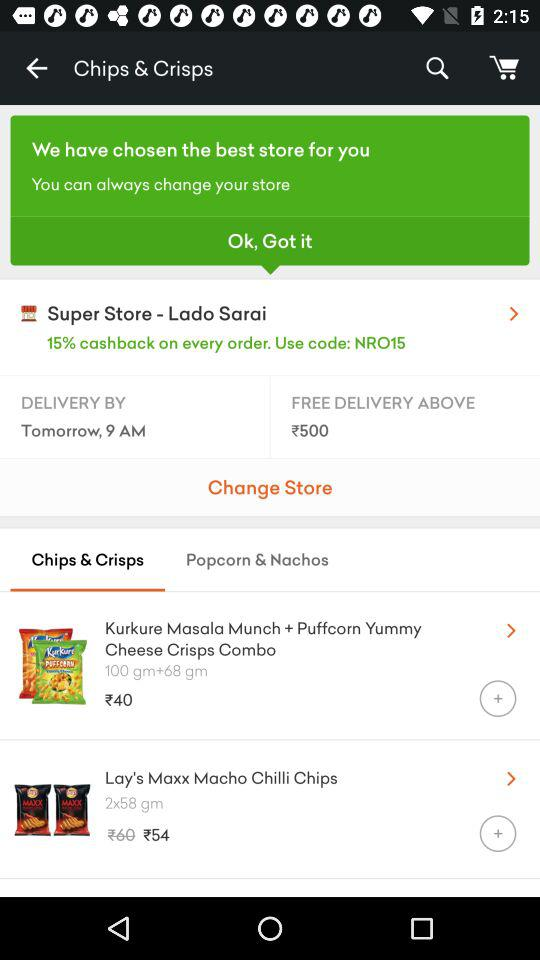What is the price of the "Kurkure Masala Munch + Puffcorn Yummy Cheese Crisps Combo"? The price of the "Kurkure Masala Munch + Puffcorn Yummy Cheese Crisps Combo" is ₹40. 